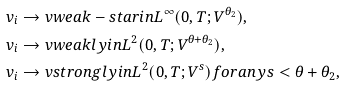Convert formula to latex. <formula><loc_0><loc_0><loc_500><loc_500>& v _ { i } \rightarrow v w e a k - s t a r i n L ^ { \infty } ( 0 , T ; V ^ { \theta _ { 2 } } ) , \\ & v _ { i } \rightarrow v w e a k l y i n L ^ { 2 } ( 0 , T ; V ^ { \theta + \theta _ { 2 } } ) , \\ & v _ { i } \rightarrow v s t r o n g l y i n L ^ { 2 } ( 0 , T ; V ^ { s } ) f o r a n y s < \theta + \theta _ { 2 } ,</formula> 